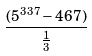Convert formula to latex. <formula><loc_0><loc_0><loc_500><loc_500>\frac { ( 5 ^ { 3 3 7 } - 4 6 7 ) } { \frac { 1 } { 3 } }</formula> 